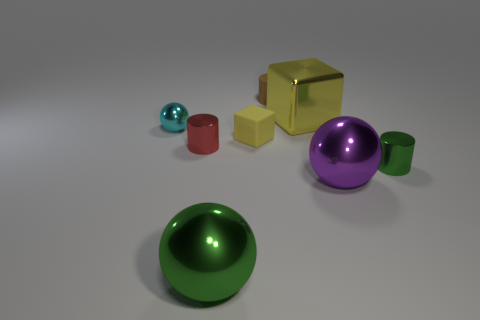There is a tiny green cylinder; what number of green cylinders are in front of it?
Keep it short and to the point. 0. Are there the same number of large green spheres that are to the right of the rubber block and purple metallic balls?
Make the answer very short. No. What number of things are tiny red metallic spheres or large blocks?
Provide a short and direct response. 1. Are there any other things that have the same shape as the large purple object?
Ensure brevity in your answer.  Yes. What is the shape of the green thing on the right side of the big object to the left of the small yellow rubber cube?
Your response must be concise. Cylinder. The other object that is the same material as the small yellow object is what shape?
Provide a short and direct response. Cylinder. What size is the green object that is to the left of the yellow object that is behind the cyan shiny thing?
Provide a succinct answer. Large. What is the shape of the red metal object?
Offer a very short reply. Cylinder. What number of big things are red shiny cylinders or cyan spheres?
Make the answer very short. 0. There is another metal thing that is the same shape as the small yellow thing; what size is it?
Your response must be concise. Large. 